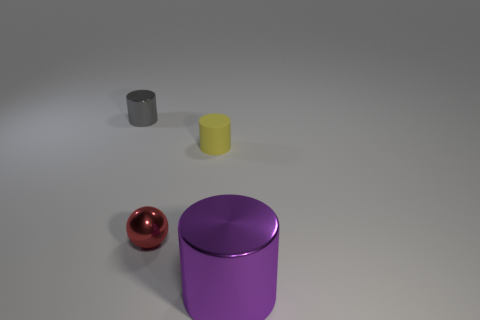How big is the metallic cylinder to the right of the metal cylinder that is on the left side of the object that is on the right side of the small rubber object?
Your answer should be compact. Large. How many things are cylinders to the right of the red shiny ball or tiny blue matte blocks?
Provide a short and direct response. 2. What number of metallic cylinders are to the right of the small cylinder behind the yellow object?
Offer a very short reply. 1. Is the number of tiny metallic spheres behind the yellow thing greater than the number of tiny gray things?
Your response must be concise. No. How big is the cylinder that is in front of the tiny metal cylinder and behind the purple shiny cylinder?
Keep it short and to the point. Small. The object that is both to the right of the red metallic thing and in front of the small yellow rubber object has what shape?
Give a very brief answer. Cylinder. Is there a purple cylinder that is right of the shiny cylinder that is in front of the shiny cylinder behind the large cylinder?
Offer a terse response. No. How many objects are either metal objects in front of the tiny red shiny thing or things on the left side of the large metal cylinder?
Give a very brief answer. 4. Are the tiny cylinder right of the gray object and the small ball made of the same material?
Provide a short and direct response. No. What is the cylinder that is in front of the gray cylinder and behind the large purple metallic cylinder made of?
Provide a short and direct response. Rubber. 